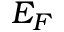<formula> <loc_0><loc_0><loc_500><loc_500>E _ { F }</formula> 